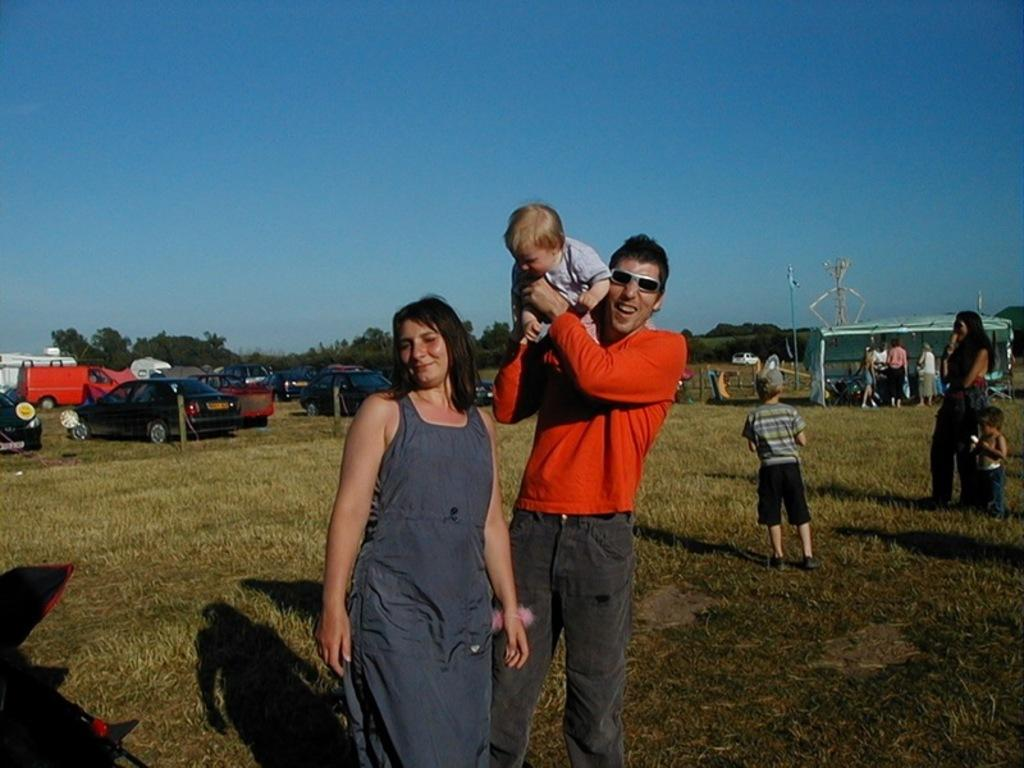Who or what can be seen in the image? There are people in the image. What is located on the left side of the image? There are vehicles on the left side of the image. What can be seen in the background of the image? There are trees and the sky visible in the background of the image. Can you see a hall in the image? There is no hall present in the image. What type of rock is being kicked by one of the people in the image? There is no rock or kicking action present in the image. 